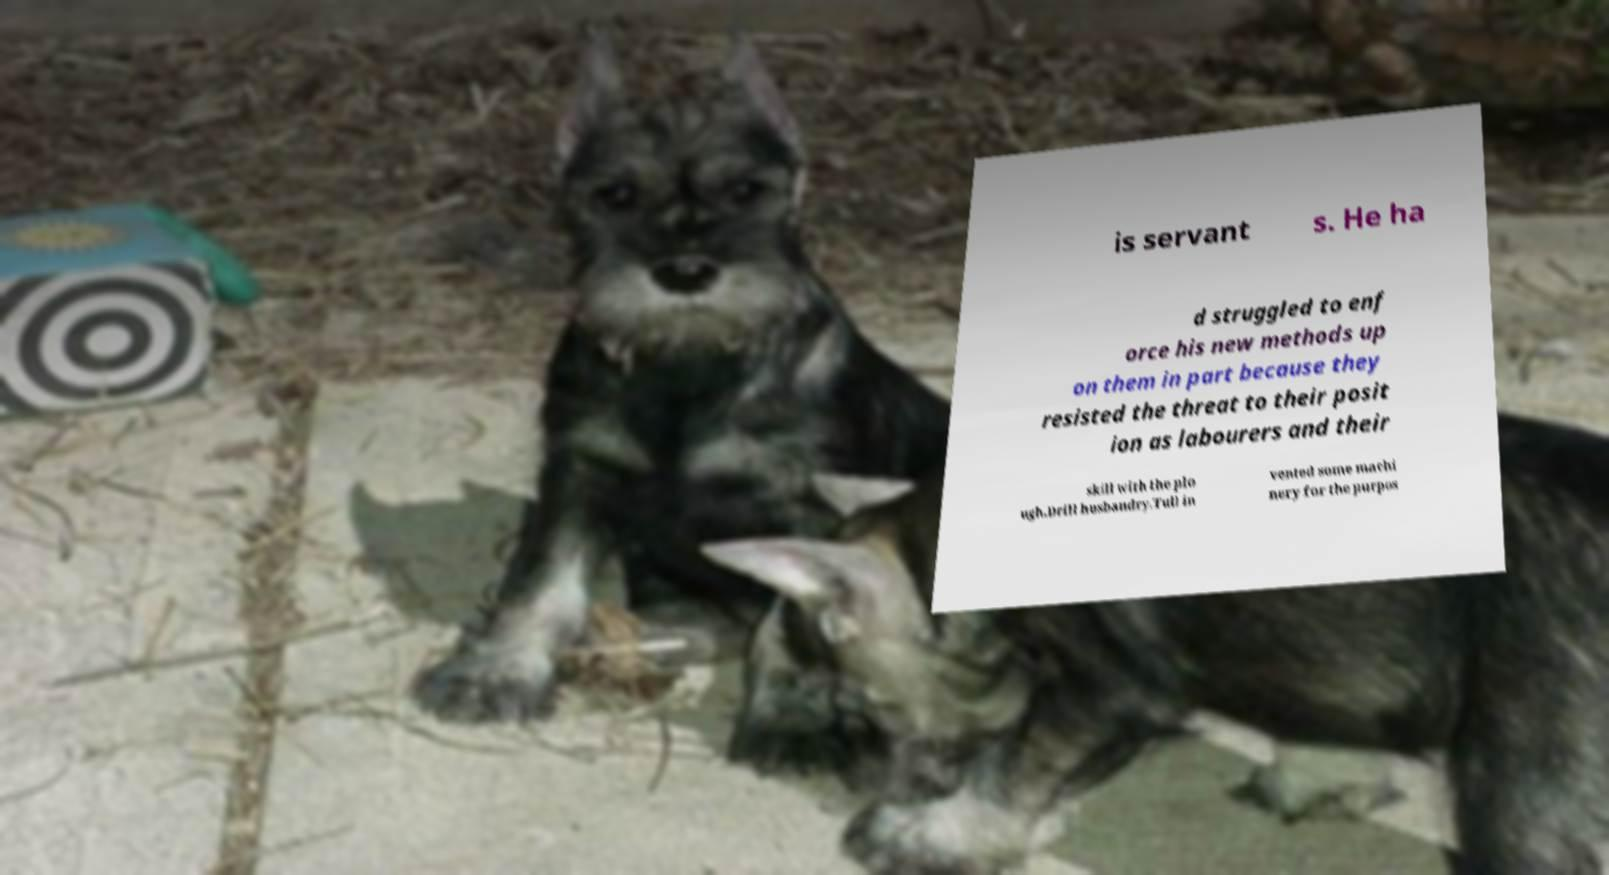Can you accurately transcribe the text from the provided image for me? is servant s. He ha d struggled to enf orce his new methods up on them in part because they resisted the threat to their posit ion as labourers and their skill with the plo ugh.Drill husbandry.Tull in vented some machi nery for the purpos 